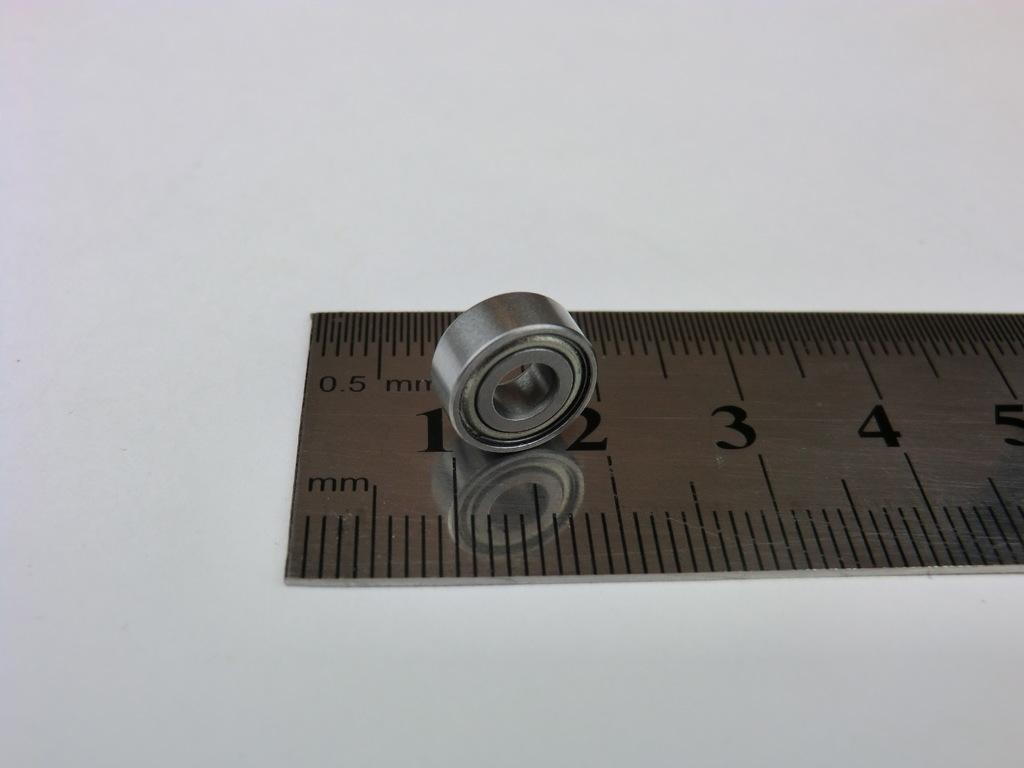What number comes after the 5?
Offer a terse response. Answering does not require reading text in the image. What are the two letters on the bottom right hand side?
Keep it short and to the point. Mm. 